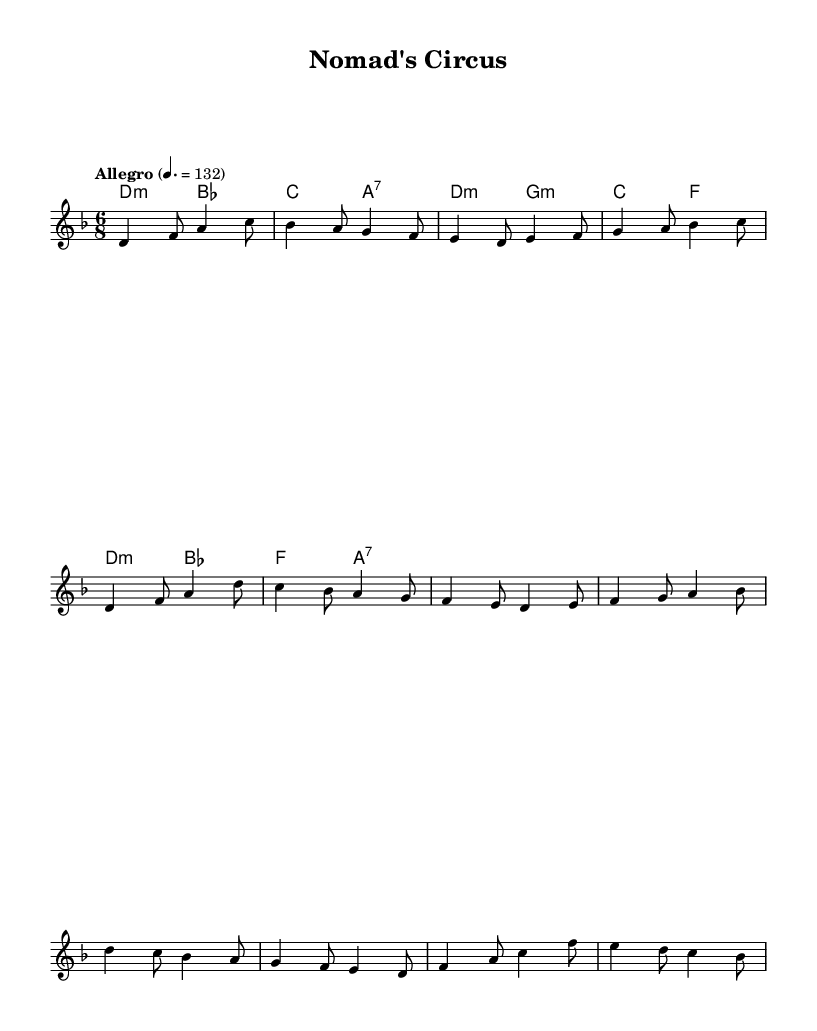What is the key signature of this music? The key signature indicated in the music is two flats, which defines the key of D minor. The flats are placed at the beginning of the staff next to the clef symbol.
Answer: D minor What is the time signature of this music? The time signature shown on the sheet is 6/8, which means there are six eighth notes in each measure. This is written at the beginning of the staff, following the key signature.
Answer: 6/8 What is the tempo marking of this piece? The tempo marking in the music states "Allegro" with a tempo of 132 beats per minute, indicating a fast speed. This marking is found at the beginning under the global section.
Answer: Allegro How many measures are in the melody section? The melody section consists of 8 measures, evident from counting each segment divided by vertical lines on the staff.
Answer: 8 Which chord is played at the beginning? The first chord in the harmony section is D minor, as indicated by the chord symbols aligned over the melody. The symbols are placed before the melody starts, confirming the harmonic structure.
Answer: D minor What musical form does this piece follow? The structure of the sheet music follows a standard verse-chorus form, as indicated by the labeled sections in the melody: intro, verse, and chorus. Each section is recognizable by its unique melodic contour.
Answer: Verse-Chorus Is this piece written for solo or ensemble performance? The music is arranged for a solo piece since it features a single staff for the melody line without additional instruments or parts indicated. The absence of multiple staves confirms that it's designed for a solo performer.
Answer: Solo 